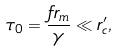<formula> <loc_0><loc_0><loc_500><loc_500>\tau _ { 0 } = \frac { f r _ { m } } { \gamma } \ll r ^ { \prime } _ { c } ,</formula> 